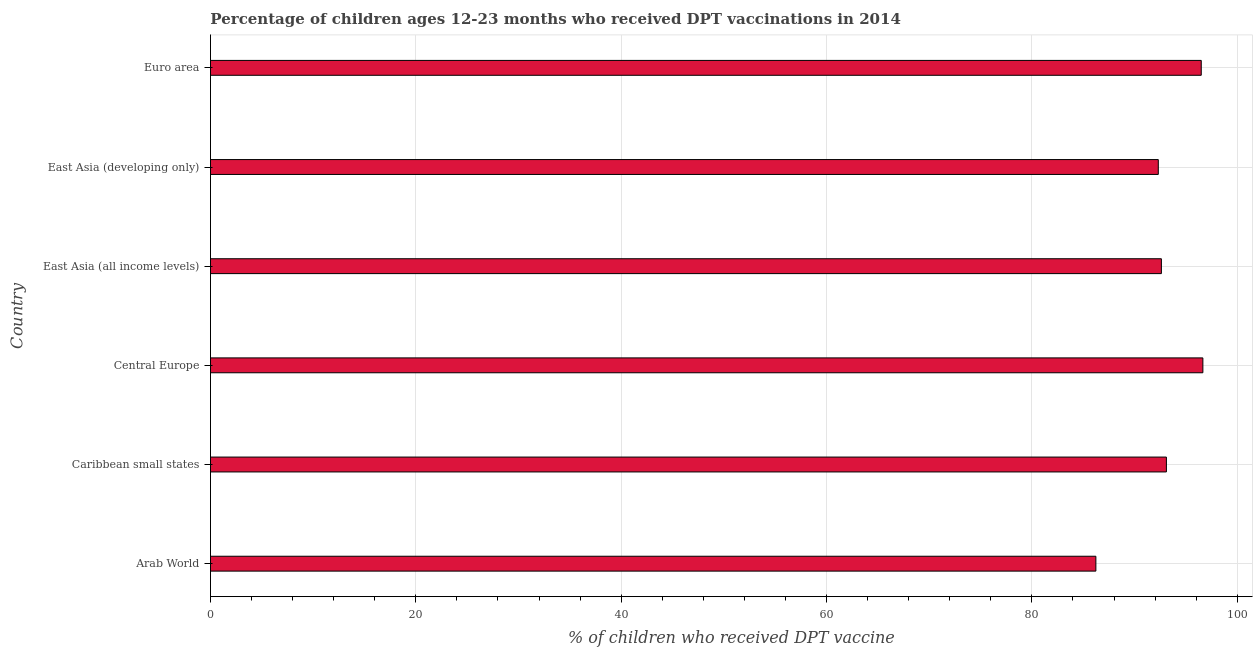Does the graph contain any zero values?
Your response must be concise. No. Does the graph contain grids?
Offer a very short reply. Yes. What is the title of the graph?
Your response must be concise. Percentage of children ages 12-23 months who received DPT vaccinations in 2014. What is the label or title of the X-axis?
Offer a terse response. % of children who received DPT vaccine. What is the percentage of children who received dpt vaccine in East Asia (all income levels)?
Keep it short and to the point. 92.61. Across all countries, what is the maximum percentage of children who received dpt vaccine?
Ensure brevity in your answer.  96.65. Across all countries, what is the minimum percentage of children who received dpt vaccine?
Ensure brevity in your answer.  86.23. In which country was the percentage of children who received dpt vaccine maximum?
Provide a succinct answer. Central Europe. In which country was the percentage of children who received dpt vaccine minimum?
Your response must be concise. Arab World. What is the sum of the percentage of children who received dpt vaccine?
Your response must be concise. 557.41. What is the difference between the percentage of children who received dpt vaccine in Caribbean small states and East Asia (all income levels)?
Ensure brevity in your answer.  0.49. What is the average percentage of children who received dpt vaccine per country?
Make the answer very short. 92.9. What is the median percentage of children who received dpt vaccine?
Your response must be concise. 92.86. What is the ratio of the percentage of children who received dpt vaccine in Central Europe to that in East Asia (all income levels)?
Offer a very short reply. 1.04. Is the percentage of children who received dpt vaccine in Arab World less than that in Euro area?
Ensure brevity in your answer.  Yes. Is the difference between the percentage of children who received dpt vaccine in Arab World and Central Europe greater than the difference between any two countries?
Keep it short and to the point. Yes. What is the difference between the highest and the second highest percentage of children who received dpt vaccine?
Ensure brevity in your answer.  0.16. Is the sum of the percentage of children who received dpt vaccine in Caribbean small states and Central Europe greater than the maximum percentage of children who received dpt vaccine across all countries?
Give a very brief answer. Yes. What is the difference between the highest and the lowest percentage of children who received dpt vaccine?
Your answer should be compact. 10.42. In how many countries, is the percentage of children who received dpt vaccine greater than the average percentage of children who received dpt vaccine taken over all countries?
Offer a very short reply. 3. How many bars are there?
Your response must be concise. 6. What is the difference between two consecutive major ticks on the X-axis?
Keep it short and to the point. 20. What is the % of children who received DPT vaccine in Arab World?
Give a very brief answer. 86.23. What is the % of children who received DPT vaccine of Caribbean small states?
Provide a succinct answer. 93.1. What is the % of children who received DPT vaccine in Central Europe?
Ensure brevity in your answer.  96.65. What is the % of children who received DPT vaccine in East Asia (all income levels)?
Keep it short and to the point. 92.61. What is the % of children who received DPT vaccine of East Asia (developing only)?
Offer a terse response. 92.31. What is the % of children who received DPT vaccine of Euro area?
Keep it short and to the point. 96.5. What is the difference between the % of children who received DPT vaccine in Arab World and Caribbean small states?
Provide a succinct answer. -6.87. What is the difference between the % of children who received DPT vaccine in Arab World and Central Europe?
Make the answer very short. -10.42. What is the difference between the % of children who received DPT vaccine in Arab World and East Asia (all income levels)?
Your answer should be very brief. -6.38. What is the difference between the % of children who received DPT vaccine in Arab World and East Asia (developing only)?
Provide a succinct answer. -6.08. What is the difference between the % of children who received DPT vaccine in Arab World and Euro area?
Make the answer very short. -10.26. What is the difference between the % of children who received DPT vaccine in Caribbean small states and Central Europe?
Your answer should be compact. -3.55. What is the difference between the % of children who received DPT vaccine in Caribbean small states and East Asia (all income levels)?
Make the answer very short. 0.49. What is the difference between the % of children who received DPT vaccine in Caribbean small states and East Asia (developing only)?
Provide a short and direct response. 0.79. What is the difference between the % of children who received DPT vaccine in Caribbean small states and Euro area?
Keep it short and to the point. -3.39. What is the difference between the % of children who received DPT vaccine in Central Europe and East Asia (all income levels)?
Your response must be concise. 4.04. What is the difference between the % of children who received DPT vaccine in Central Europe and East Asia (developing only)?
Your response must be concise. 4.34. What is the difference between the % of children who received DPT vaccine in Central Europe and Euro area?
Provide a succinct answer. 0.16. What is the difference between the % of children who received DPT vaccine in East Asia (all income levels) and East Asia (developing only)?
Your response must be concise. 0.3. What is the difference between the % of children who received DPT vaccine in East Asia (all income levels) and Euro area?
Offer a terse response. -3.88. What is the difference between the % of children who received DPT vaccine in East Asia (developing only) and Euro area?
Provide a succinct answer. -4.18. What is the ratio of the % of children who received DPT vaccine in Arab World to that in Caribbean small states?
Your response must be concise. 0.93. What is the ratio of the % of children who received DPT vaccine in Arab World to that in Central Europe?
Provide a short and direct response. 0.89. What is the ratio of the % of children who received DPT vaccine in Arab World to that in East Asia (developing only)?
Your response must be concise. 0.93. What is the ratio of the % of children who received DPT vaccine in Arab World to that in Euro area?
Give a very brief answer. 0.89. What is the ratio of the % of children who received DPT vaccine in Caribbean small states to that in East Asia (all income levels)?
Your answer should be very brief. 1. What is the ratio of the % of children who received DPT vaccine in Caribbean small states to that in East Asia (developing only)?
Your response must be concise. 1.01. What is the ratio of the % of children who received DPT vaccine in Caribbean small states to that in Euro area?
Your answer should be very brief. 0.96. What is the ratio of the % of children who received DPT vaccine in Central Europe to that in East Asia (all income levels)?
Offer a terse response. 1.04. What is the ratio of the % of children who received DPT vaccine in Central Europe to that in East Asia (developing only)?
Provide a succinct answer. 1.05. What is the ratio of the % of children who received DPT vaccine in East Asia (developing only) to that in Euro area?
Your response must be concise. 0.96. 